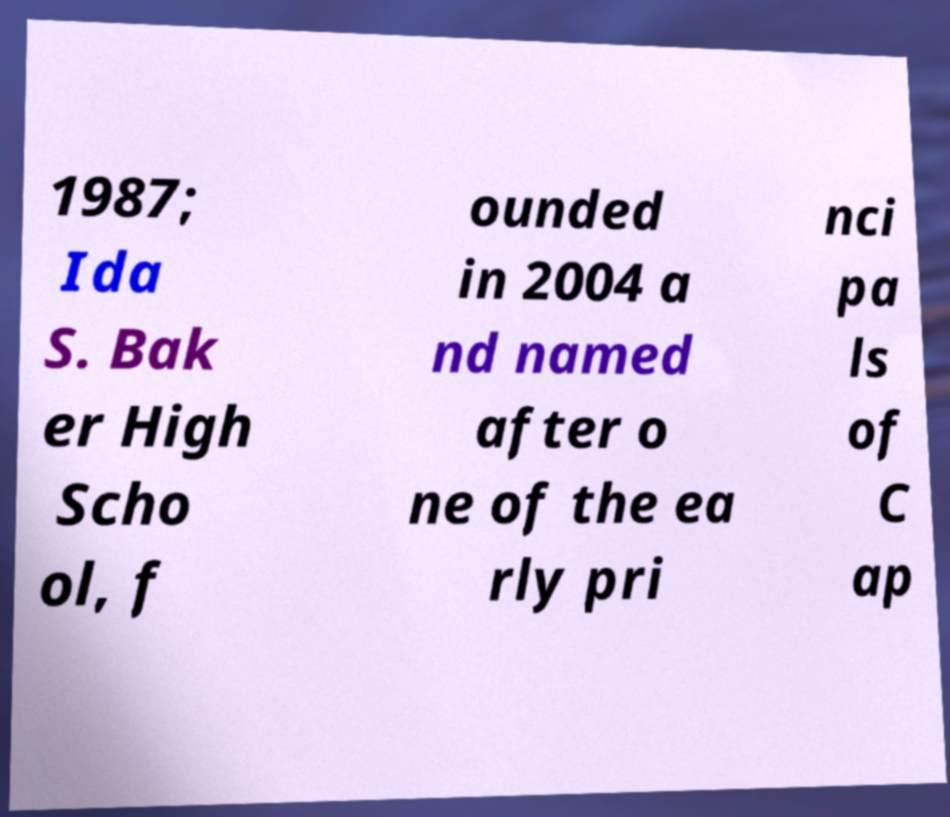For documentation purposes, I need the text within this image transcribed. Could you provide that? 1987; Ida S. Bak er High Scho ol, f ounded in 2004 a nd named after o ne of the ea rly pri nci pa ls of C ap 